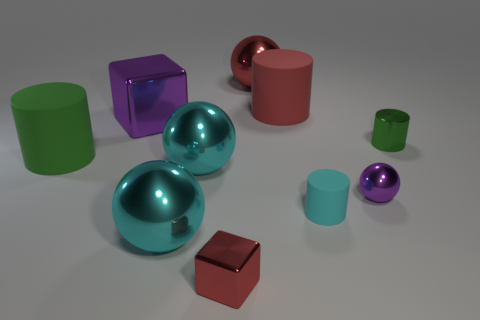Subtract 2 cylinders. How many cylinders are left? 2 Subtract all small green metallic cylinders. How many cylinders are left? 3 Subtract all red balls. How many balls are left? 3 Subtract all blue balls. Subtract all red cylinders. How many balls are left? 4 Subtract all balls. How many objects are left? 6 Subtract 1 purple cubes. How many objects are left? 9 Subtract all big cylinders. Subtract all tiny shiny cylinders. How many objects are left? 7 Add 6 matte cylinders. How many matte cylinders are left? 9 Add 5 small cyan metal blocks. How many small cyan metal blocks exist? 5 